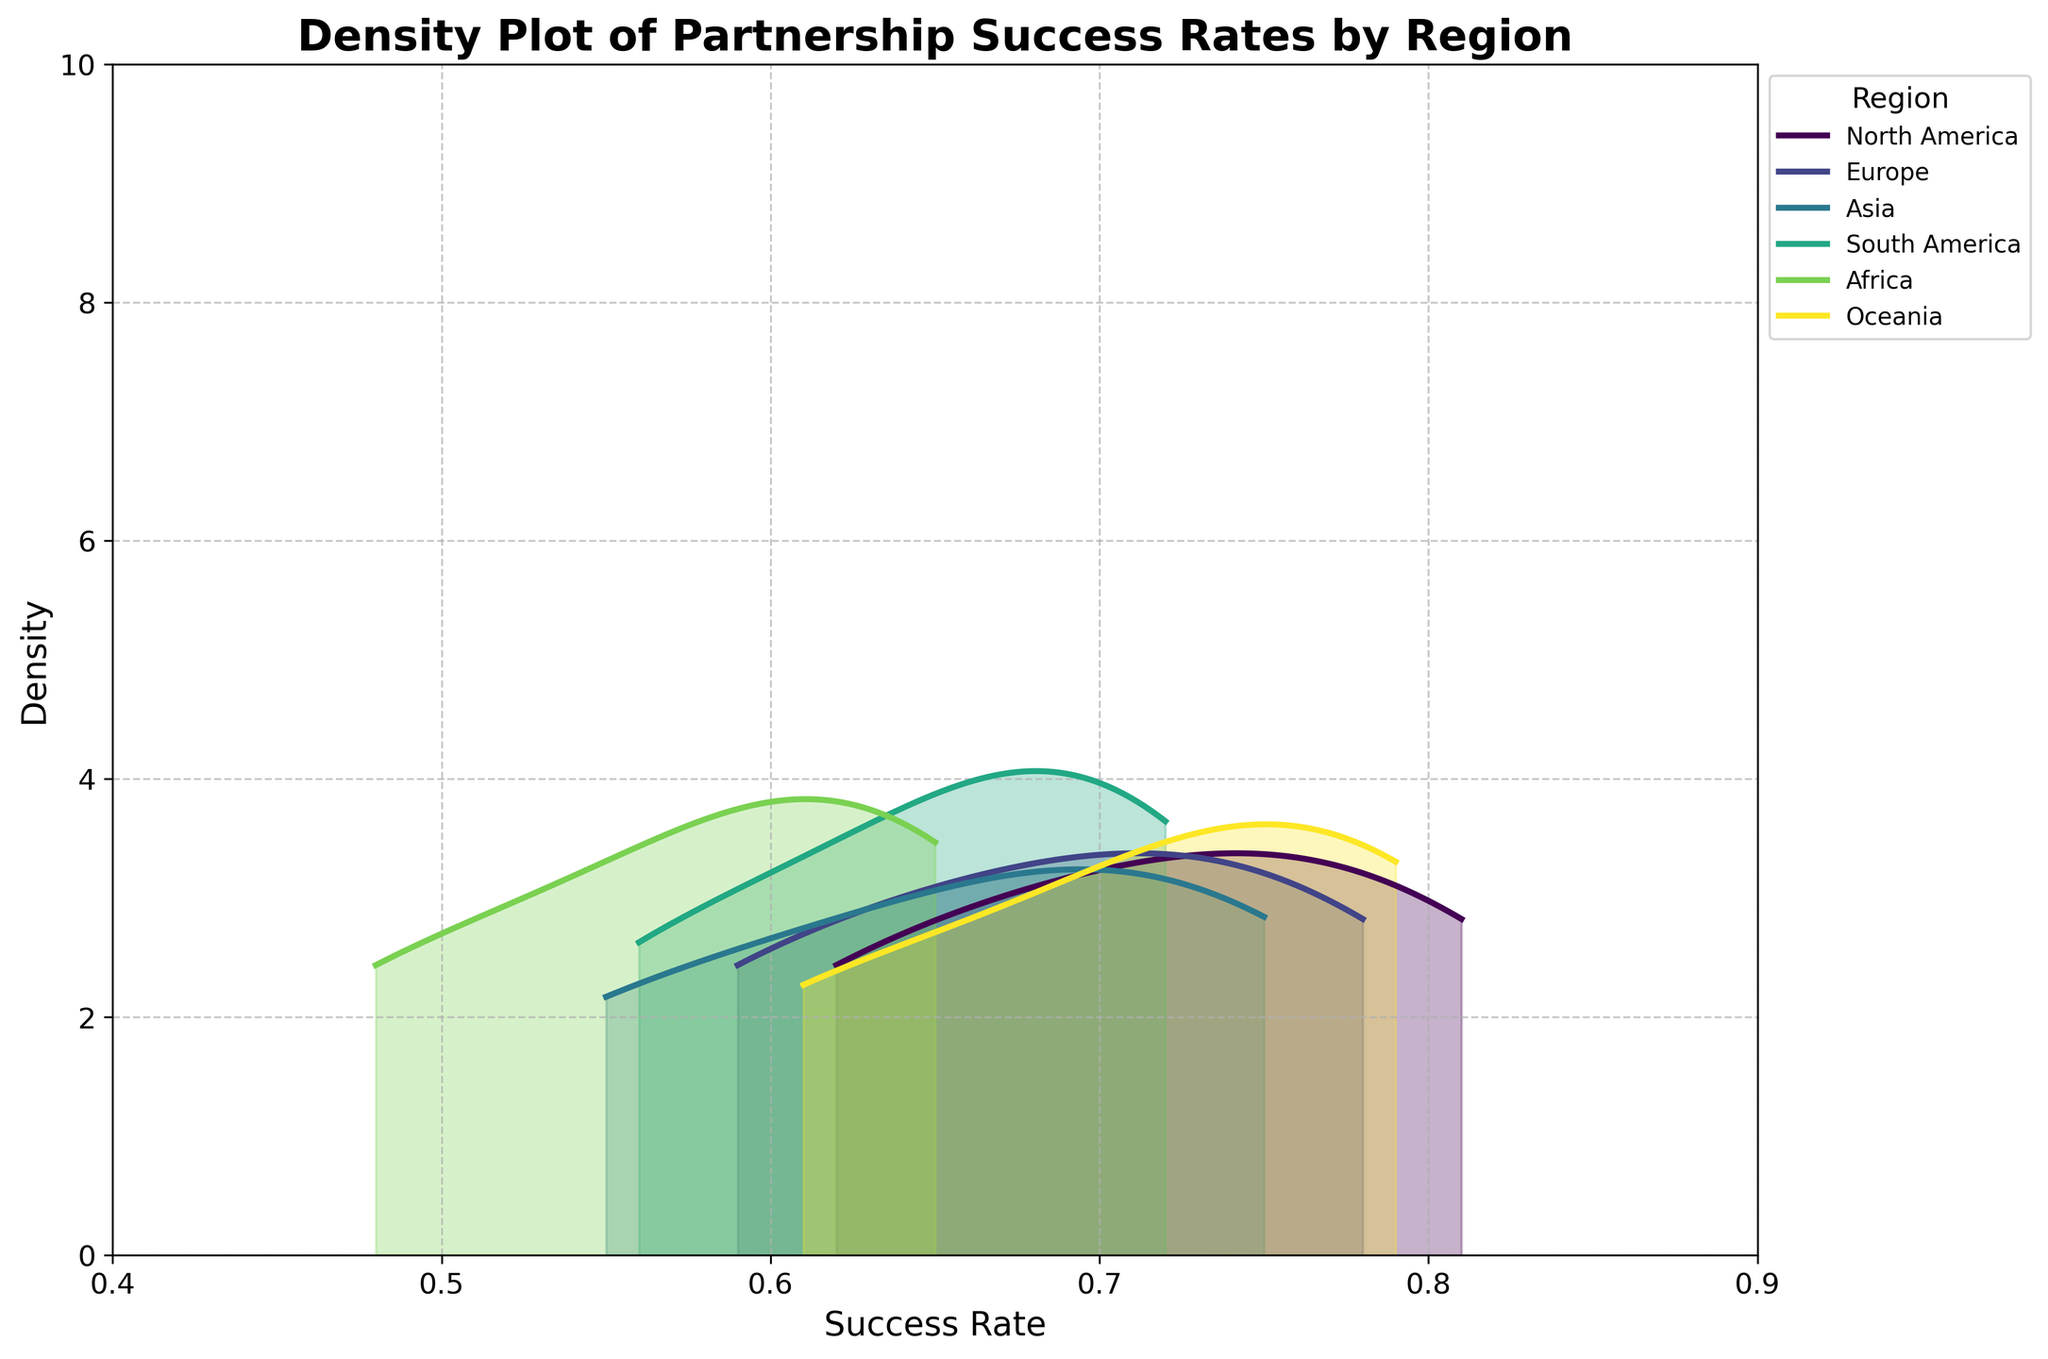What is the title of the plot? The plot displays a title at the top which serves as a brief description of its content.
Answer: Density Plot of Partnership Success Rates by Region Which region has the highest peak density in the plot? By observing the height of the peak densities in the plot, we can check which region has the highest value.
Answer: North America What is the success rate range displayed on the x-axis? The value range of the x-axis can be determined by looking at the labels that mark the minimum and maximum limits.
Answer: 0.4 to 0.9 How many regions are displayed in the legend? The legend lists all the regions with their corresponding colors that are represented in the density plot. Count these entries.
Answer: 6 Which region has the widest distribution of success rates? The width of the distribution can be inferred by looking at how spread out the density function is across the x-axis for each region.
Answer: Africa Which region exhibits the narrowest density spread, indicating the most consistent success rates? The region with the least spread on the x-axis has the narrowest distribution.
Answer: Oceania Comparatively, which regions have higher success rates on average, North America or Africa? Comparing the center or the peaks of the density curves of North America and Africa, we can determine which has the higher average success rate.
Answer: North America What approximate success rate range captures the highest density for Europe? Look at the x-axis range where Europe's density curve has its highest values to determine this range.
Answer: 0.65 to 0.75 Is Oceania’s success rate distribution skewed to the left or right, and what does this imply? Observing the shape of Oceania's density curve can tell us if it is skewed (has a longer tail) to one side, which implies more frequencies of success rates on the other side.
Answer: Right-skewed; higher success rates are more frequent 